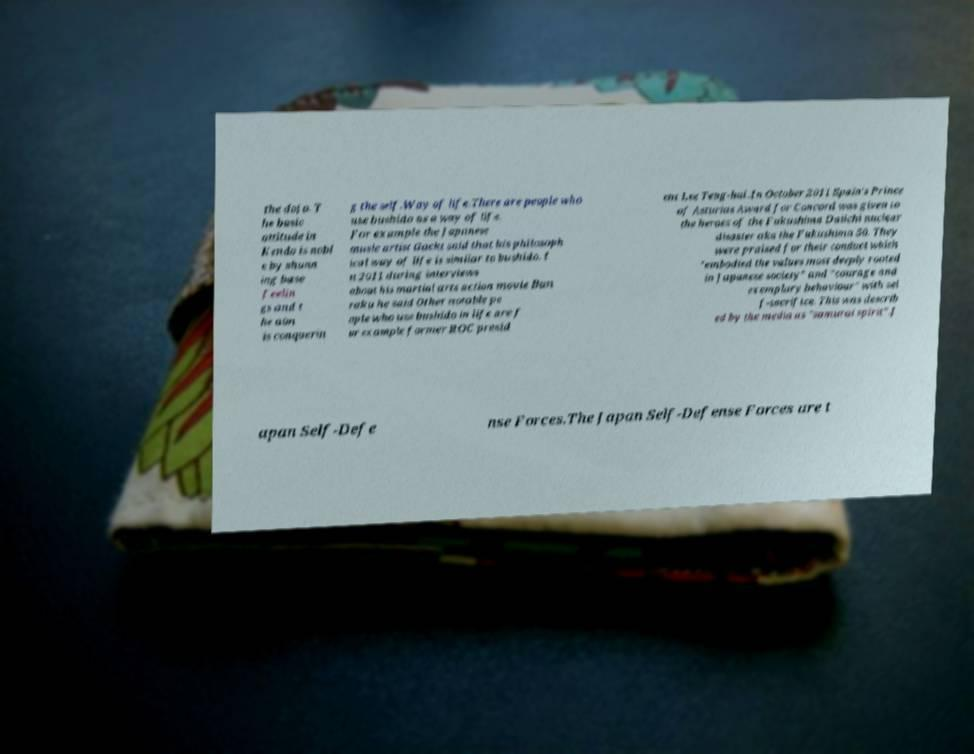I need the written content from this picture converted into text. Can you do that? the dojo. T he basic attitude in Kendo is nobl e by shunn ing base feelin gs and t he aim is conquerin g the self.Way of life.There are people who use bushido as a way of life. For example the Japanese music artist Gackt said that his philosoph ical way of life is similar to bushido. I n 2011 during interviews about his martial arts action movie Bun raku he said Other notable pe ople who use bushido in life are f or example former ROC presid ent Lee Teng-hui .In October 2011 Spain's Prince of Asturias Award for Concord was given to the heroes of the Fukushima Daiichi nuclear disaster aka the Fukushima 50. They were praised for their conduct which "embodied the values most deeply rooted in Japanese society" and "courage and exemplary behaviour" with sel f-sacrifice. This was describ ed by the media as "samurai spirit".J apan Self-Defe nse Forces.The Japan Self-Defense Forces are t 